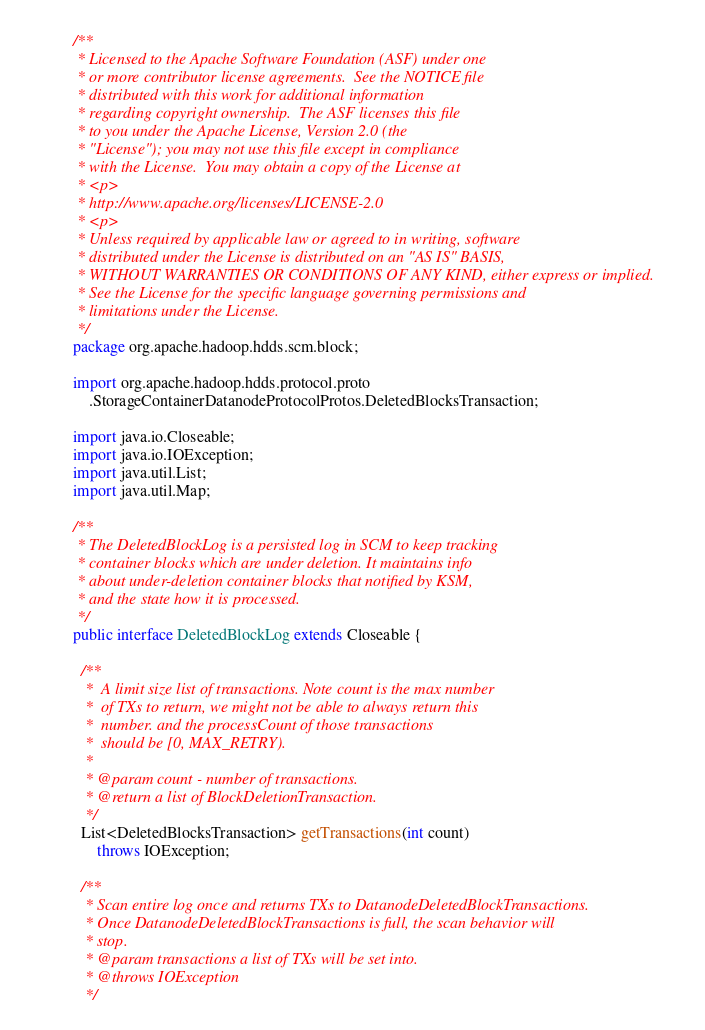Convert code to text. <code><loc_0><loc_0><loc_500><loc_500><_Java_>/**
 * Licensed to the Apache Software Foundation (ASF) under one
 * or more contributor license agreements.  See the NOTICE file
 * distributed with this work for additional information
 * regarding copyright ownership.  The ASF licenses this file
 * to you under the Apache License, Version 2.0 (the
 * "License"); you may not use this file except in compliance
 * with the License.  You may obtain a copy of the License at
 * <p>
 * http://www.apache.org/licenses/LICENSE-2.0
 * <p>
 * Unless required by applicable law or agreed to in writing, software
 * distributed under the License is distributed on an "AS IS" BASIS,
 * WITHOUT WARRANTIES OR CONDITIONS OF ANY KIND, either express or implied.
 * See the License for the specific language governing permissions and
 * limitations under the License.
 */
package org.apache.hadoop.hdds.scm.block;

import org.apache.hadoop.hdds.protocol.proto
    .StorageContainerDatanodeProtocolProtos.DeletedBlocksTransaction;

import java.io.Closeable;
import java.io.IOException;
import java.util.List;
import java.util.Map;

/**
 * The DeletedBlockLog is a persisted log in SCM to keep tracking
 * container blocks which are under deletion. It maintains info
 * about under-deletion container blocks that notified by KSM,
 * and the state how it is processed.
 */
public interface DeletedBlockLog extends Closeable {

  /**
   *  A limit size list of transactions. Note count is the max number
   *  of TXs to return, we might not be able to always return this
   *  number. and the processCount of those transactions
   *  should be [0, MAX_RETRY).
   *
   * @param count - number of transactions.
   * @return a list of BlockDeletionTransaction.
   */
  List<DeletedBlocksTransaction> getTransactions(int count)
      throws IOException;

  /**
   * Scan entire log once and returns TXs to DatanodeDeletedBlockTransactions.
   * Once DatanodeDeletedBlockTransactions is full, the scan behavior will
   * stop.
   * @param transactions a list of TXs will be set into.
   * @throws IOException
   */</code> 